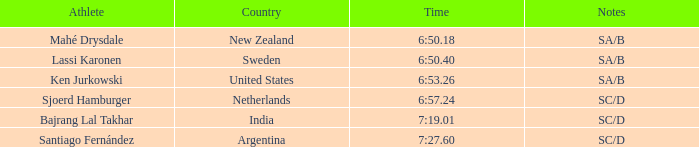What is the top position for the team that achieved a time of 6:5 2.0. 